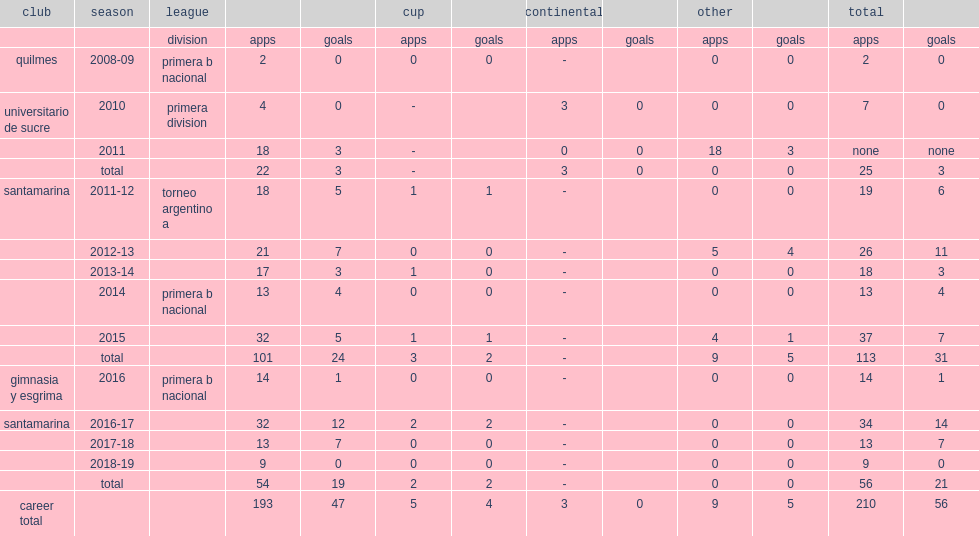Which club did martin michel play for torneo argentino a, in 2013-14? Santamarina. Would you mind parsing the complete table? {'header': ['club', 'season', 'league', '', '', 'cup', '', 'continental', '', 'other', '', 'total', ''], 'rows': [['', '', 'division', 'apps', 'goals', 'apps', 'goals', 'apps', 'goals', 'apps', 'goals', 'apps', 'goals'], ['quilmes', '2008-09', 'primera b nacional', '2', '0', '0', '0', '-', '', '0', '0', '2', '0'], ['universitario de sucre', '2010', 'primera division', '4', '0', '-', '', '3', '0', '0', '0', '7', '0'], ['', '2011', '', '18', '3', '-', '', '0', '0', '18', '3', 'none', 'none'], ['', 'total', '', '22', '3', '-', '', '3', '0', '0', '0', '25', '3'], ['santamarina', '2011-12', 'torneo argentino a', '18', '5', '1', '1', '-', '', '0', '0', '19', '6'], ['', '2012-13', '', '21', '7', '0', '0', '-', '', '5', '4', '26', '11'], ['', '2013-14', '', '17', '3', '1', '0', '-', '', '0', '0', '18', '3'], ['', '2014', 'primera b nacional', '13', '4', '0', '0', '-', '', '0', '0', '13', '4'], ['', '2015', '', '32', '5', '1', '1', '-', '', '4', '1', '37', '7'], ['', 'total', '', '101', '24', '3', '2', '-', '', '9', '5', '113', '31'], ['gimnasia y esgrima', '2016', 'primera b nacional', '14', '1', '0', '0', '-', '', '0', '0', '14', '1'], ['santamarina', '2016-17', '', '32', '12', '2', '2', '-', '', '0', '0', '34', '14'], ['', '2017-18', '', '13', '7', '0', '0', '-', '', '0', '0', '13', '7'], ['', '2018-19', '', '9', '0', '0', '0', '-', '', '0', '0', '9', '0'], ['', 'total', '', '54', '19', '2', '2', '-', '', '0', '0', '56', '21'], ['career total', '', '', '193', '47', '5', '4', '3', '0', '9', '5', '210', '56']]} 